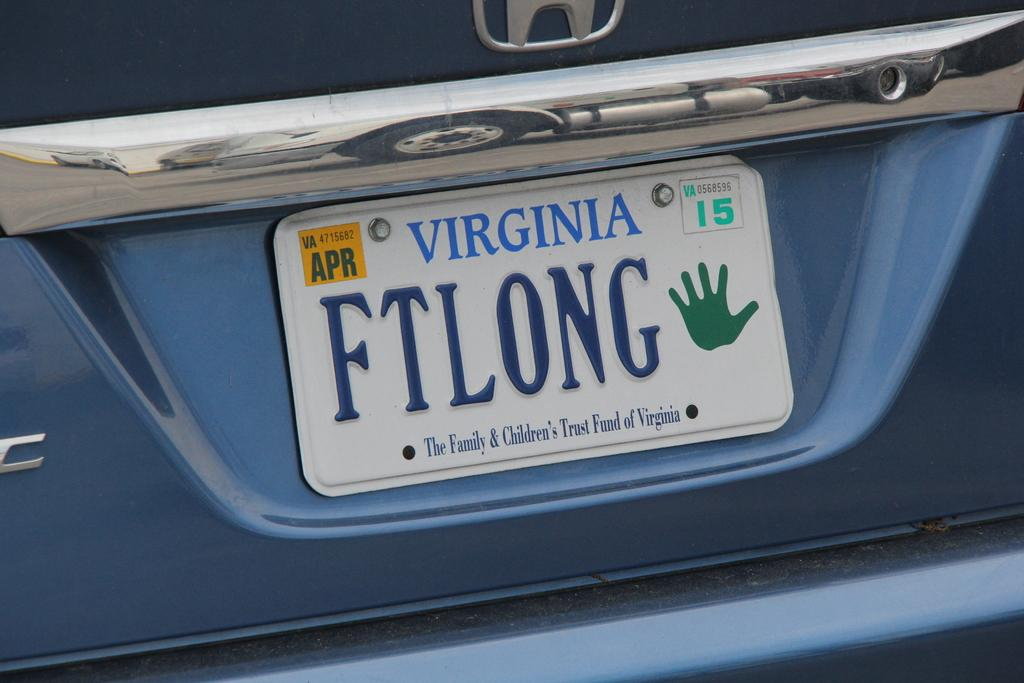<image>
Present a compact description of the photo's key features. The license plate indicates support of the Family & Children's Trust Fund of Virginia. 